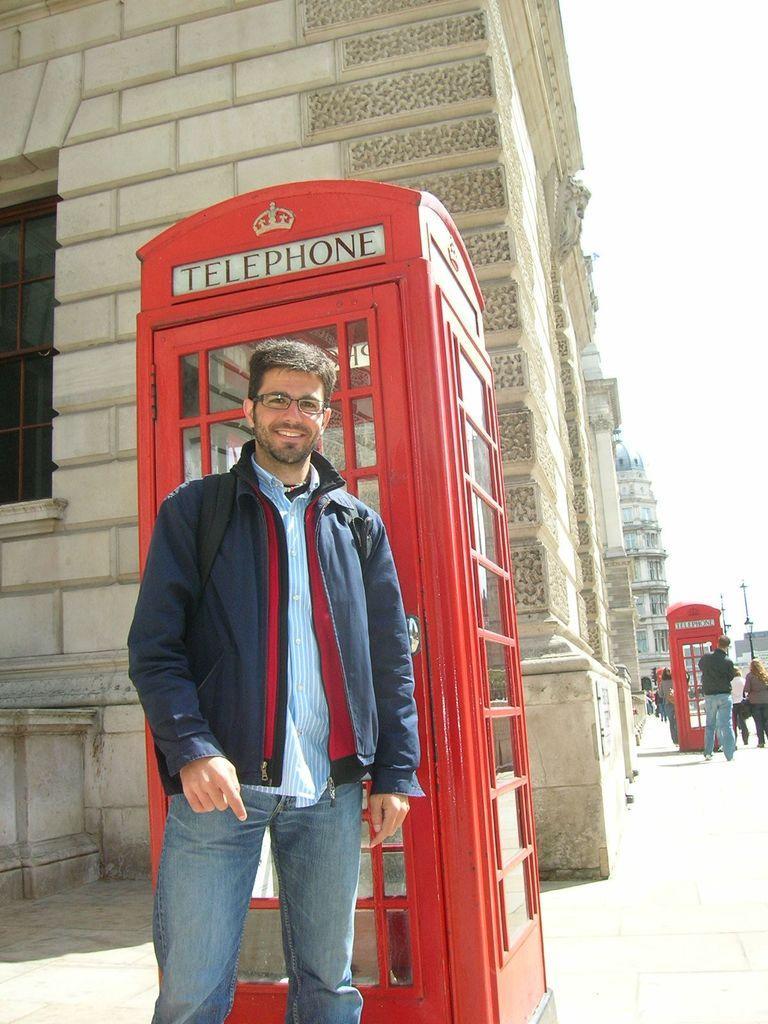How would you summarize this image in a sentence or two? In the image in the center, we can see one person standing and he is smiling. In the background, we can see the sky, buildings, telephone booths, trees and few people are standing. 